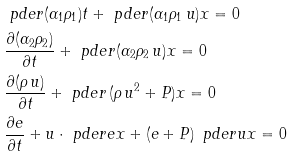Convert formula to latex. <formula><loc_0><loc_0><loc_500><loc_500>& \ p d e r { ( \alpha _ { 1 } \rho _ { 1 } ) } { t } + \ p d e r { ( \alpha _ { 1 } \rho _ { 1 } \, u ) } { x } = 0 \\ & \frac { \partial ( \alpha _ { 2 } \rho _ { 2 } ) } { \partial t } + \ p d e r { ( \alpha _ { 2 } \rho _ { 2 } \, u ) } { x } = 0 \\ & \frac { \partial ( \rho \, u ) } { \partial t } + \ p d e r { \, ( \rho \, u ^ { 2 } + P ) } { x } = 0 \\ & \frac { \partial e } { \partial t } + u \cdot \ p d e r { e } { x } + ( e + P ) \, \ p d e r { u } { x } = 0</formula> 